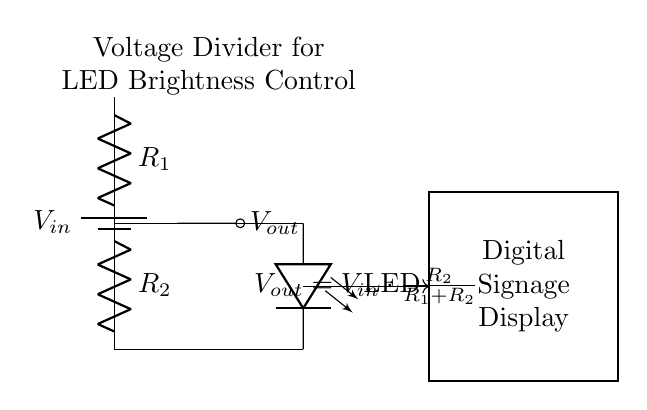What is the input voltage of the circuit? The input voltage is denoted as V_in, which is the voltage provided by the battery.
Answer: V_in What are the resistor values in the voltage divider? The circuit includes two resistors labeled as R_1 and R_2, which form the voltage divider. The specific values are not given in the diagram but are essential for calculating the output voltage.
Answer: R_1 and R_2 What is the output voltage formula for this divider? The output voltage is given by the formula V_out = V_in * (R_2 / (R_1 + R_2)), which calculates the voltage across R_2 in proportion to the input voltage and resistance values.
Answer: V_out = V_in * (R_2 / (R_1 + R_2)) How does changing R_2 affect LED brightness? Increasing R_2 decreases output voltage V_out, which dimmer the LED; a lower R_2 value increases V_out, making the LED brighter. This relationship arises from the voltage divider principle.
Answer: Decrease for dimmer, increase for brighter What is the purpose of the LED in this circuit? The LED serves as an indicator to visualize the output voltage level, shining brighter with a higher V_out and dimmer with a lower V_out, which is controlled by the voltage divider.
Answer: Brightness indicator How does the voltage divider control the LED brightness? The voltage divider allows the user to adjust the ratio of R_1 to R_2, affecting V_out; this, in turn, modulates the current flowing through the LED, thereby controlling its brightness.
Answer: It adjusts voltage and current What would happen if R_1 is much larger than R_2? If R_1 is much larger than R_2, the output voltage V_out would be significantly less than V_in, resulting in a dimmer LED since less voltage is across it. This occurs because the majority of voltage drops across R_1.
Answer: LED would be dim 